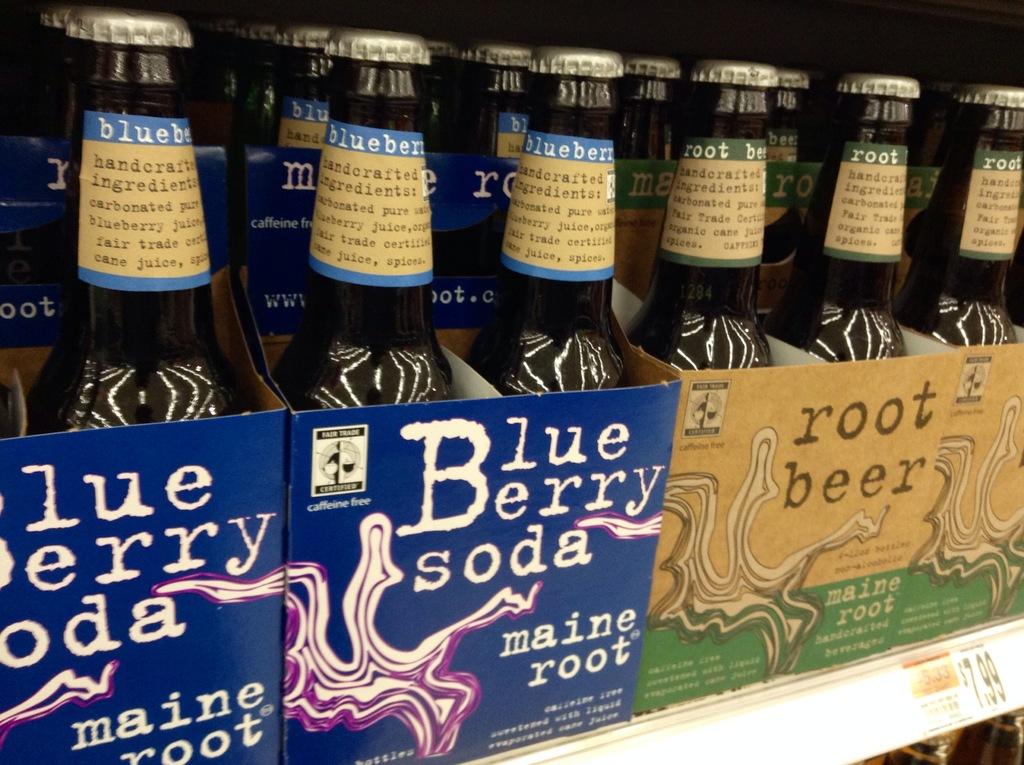What company makes both these beverages?
Offer a terse response. Maine root. What flavor is the soda on the left?
Offer a very short reply. Blueberry. 